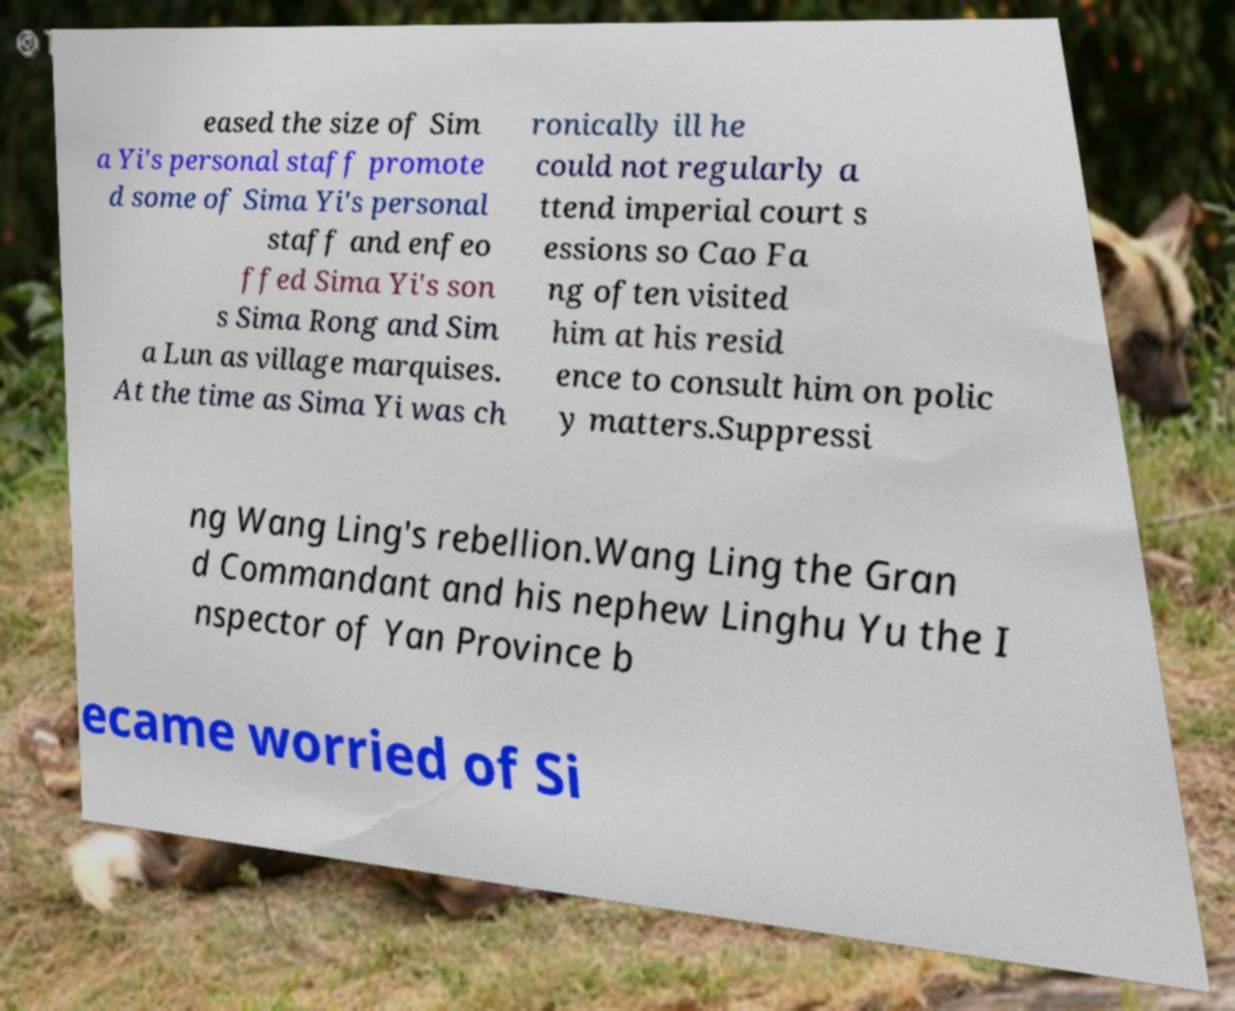Please read and relay the text visible in this image. What does it say? eased the size of Sim a Yi's personal staff promote d some of Sima Yi's personal staff and enfeo ffed Sima Yi's son s Sima Rong and Sim a Lun as village marquises. At the time as Sima Yi was ch ronically ill he could not regularly a ttend imperial court s essions so Cao Fa ng often visited him at his resid ence to consult him on polic y matters.Suppressi ng Wang Ling's rebellion.Wang Ling the Gran d Commandant and his nephew Linghu Yu the I nspector of Yan Province b ecame worried of Si 